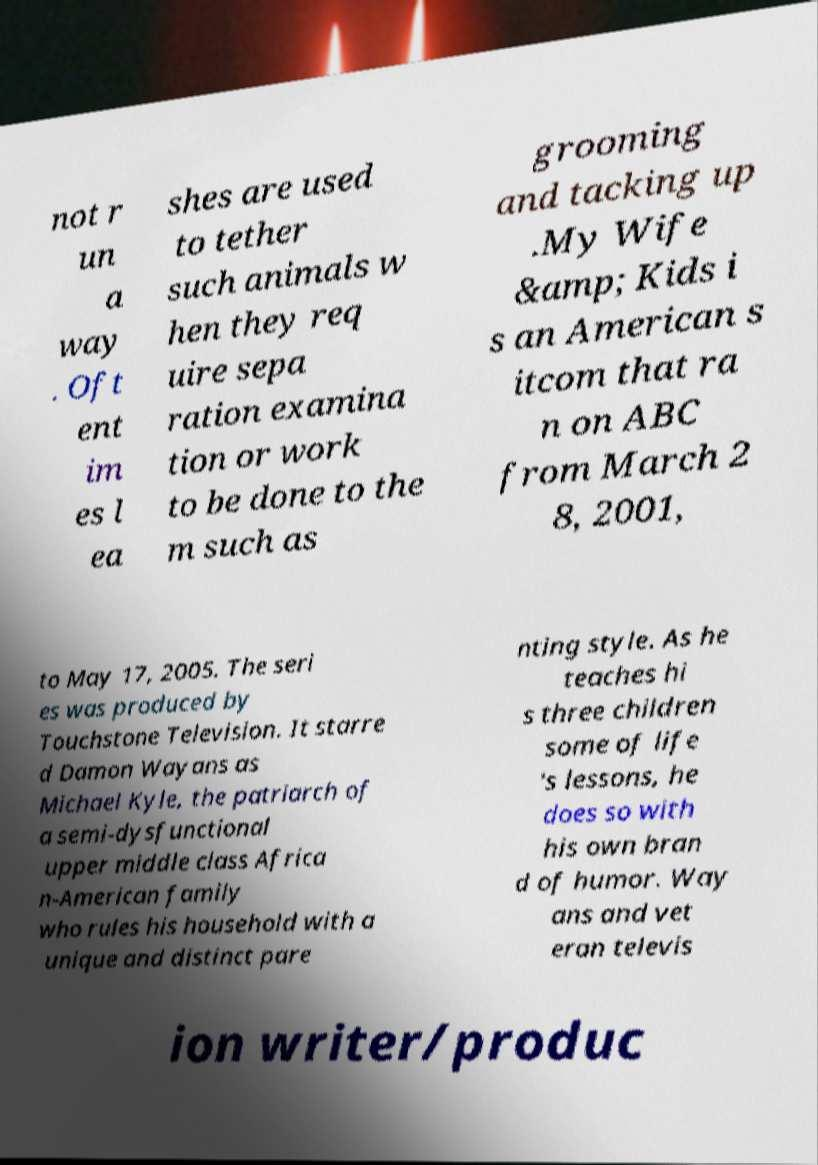I need the written content from this picture converted into text. Can you do that? not r un a way . Oft ent im es l ea shes are used to tether such animals w hen they req uire sepa ration examina tion or work to be done to the m such as grooming and tacking up .My Wife &amp; Kids i s an American s itcom that ra n on ABC from March 2 8, 2001, to May 17, 2005. The seri es was produced by Touchstone Television. It starre d Damon Wayans as Michael Kyle, the patriarch of a semi-dysfunctional upper middle class Africa n-American family who rules his household with a unique and distinct pare nting style. As he teaches hi s three children some of life 's lessons, he does so with his own bran d of humor. Way ans and vet eran televis ion writer/produc 